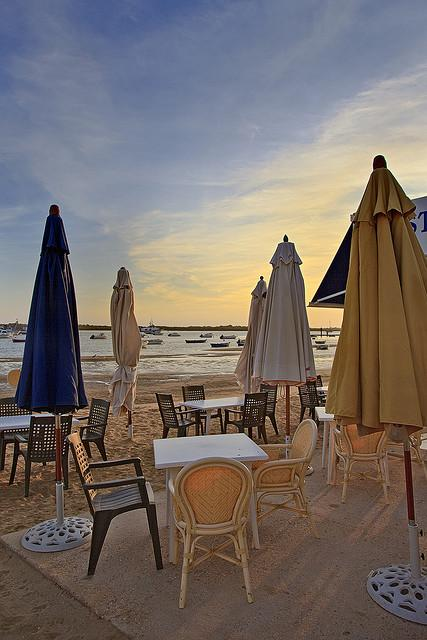What is near the table?

Choices:
A) cow
B) baby
C) cat
D) chair chair 